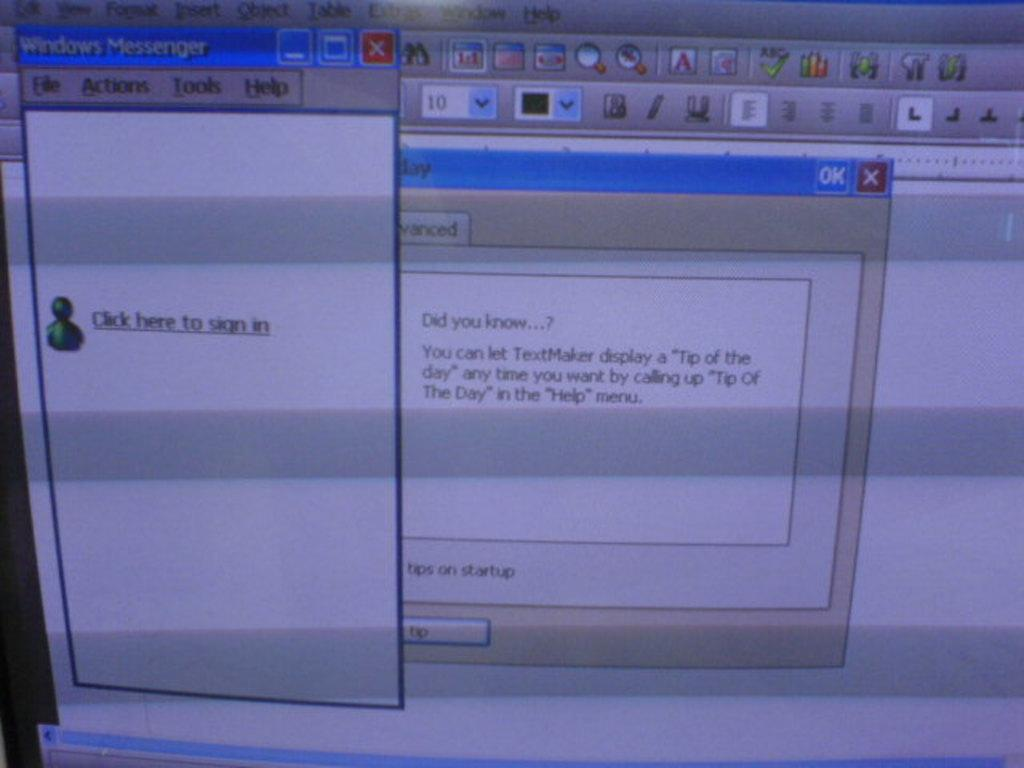<image>
Offer a succinct explanation of the picture presented. A Windows Messenger window tells the user to "click here to sign in". 